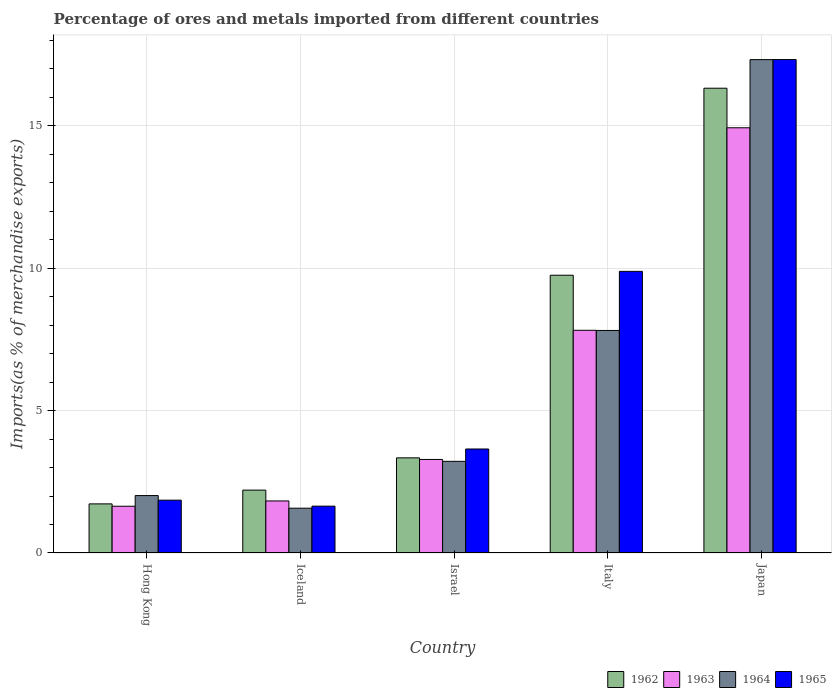How many different coloured bars are there?
Your response must be concise. 4. Are the number of bars per tick equal to the number of legend labels?
Offer a very short reply. Yes. How many bars are there on the 3rd tick from the left?
Your answer should be very brief. 4. How many bars are there on the 1st tick from the right?
Offer a very short reply. 4. What is the percentage of imports to different countries in 1964 in Israel?
Your answer should be very brief. 3.22. Across all countries, what is the maximum percentage of imports to different countries in 1962?
Keep it short and to the point. 16.32. Across all countries, what is the minimum percentage of imports to different countries in 1965?
Your response must be concise. 1.64. In which country was the percentage of imports to different countries in 1963 maximum?
Offer a very short reply. Japan. What is the total percentage of imports to different countries in 1965 in the graph?
Provide a succinct answer. 34.36. What is the difference between the percentage of imports to different countries in 1965 in Italy and that in Japan?
Your response must be concise. -7.44. What is the difference between the percentage of imports to different countries in 1962 in Hong Kong and the percentage of imports to different countries in 1964 in Israel?
Provide a short and direct response. -1.49. What is the average percentage of imports to different countries in 1964 per country?
Ensure brevity in your answer.  6.39. What is the difference between the percentage of imports to different countries of/in 1965 and percentage of imports to different countries of/in 1964 in Hong Kong?
Keep it short and to the point. -0.16. In how many countries, is the percentage of imports to different countries in 1963 greater than 5 %?
Your answer should be compact. 2. What is the ratio of the percentage of imports to different countries in 1964 in Israel to that in Italy?
Your answer should be compact. 0.41. Is the difference between the percentage of imports to different countries in 1965 in Israel and Italy greater than the difference between the percentage of imports to different countries in 1964 in Israel and Italy?
Keep it short and to the point. No. What is the difference between the highest and the second highest percentage of imports to different countries in 1963?
Offer a terse response. -11.64. What is the difference between the highest and the lowest percentage of imports to different countries in 1964?
Keep it short and to the point. 15.75. What does the 2nd bar from the left in Iceland represents?
Ensure brevity in your answer.  1963. How many bars are there?
Ensure brevity in your answer.  20. Are all the bars in the graph horizontal?
Make the answer very short. No. How many countries are there in the graph?
Keep it short and to the point. 5. What is the difference between two consecutive major ticks on the Y-axis?
Your answer should be compact. 5. Are the values on the major ticks of Y-axis written in scientific E-notation?
Provide a succinct answer. No. Does the graph contain any zero values?
Your answer should be very brief. No. Where does the legend appear in the graph?
Make the answer very short. Bottom right. How are the legend labels stacked?
Keep it short and to the point. Horizontal. What is the title of the graph?
Offer a terse response. Percentage of ores and metals imported from different countries. Does "1965" appear as one of the legend labels in the graph?
Your response must be concise. Yes. What is the label or title of the X-axis?
Offer a very short reply. Country. What is the label or title of the Y-axis?
Your answer should be very brief. Imports(as % of merchandise exports). What is the Imports(as % of merchandise exports) of 1962 in Hong Kong?
Your response must be concise. 1.72. What is the Imports(as % of merchandise exports) of 1963 in Hong Kong?
Make the answer very short. 1.64. What is the Imports(as % of merchandise exports) in 1964 in Hong Kong?
Your answer should be very brief. 2.02. What is the Imports(as % of merchandise exports) of 1965 in Hong Kong?
Your answer should be compact. 1.85. What is the Imports(as % of merchandise exports) of 1962 in Iceland?
Give a very brief answer. 2.21. What is the Imports(as % of merchandise exports) in 1963 in Iceland?
Ensure brevity in your answer.  1.83. What is the Imports(as % of merchandise exports) of 1964 in Iceland?
Provide a succinct answer. 1.57. What is the Imports(as % of merchandise exports) in 1965 in Iceland?
Offer a very short reply. 1.64. What is the Imports(as % of merchandise exports) in 1962 in Israel?
Make the answer very short. 3.34. What is the Imports(as % of merchandise exports) of 1963 in Israel?
Offer a very short reply. 3.28. What is the Imports(as % of merchandise exports) of 1964 in Israel?
Your answer should be compact. 3.22. What is the Imports(as % of merchandise exports) of 1965 in Israel?
Offer a very short reply. 3.65. What is the Imports(as % of merchandise exports) in 1962 in Italy?
Offer a very short reply. 9.75. What is the Imports(as % of merchandise exports) of 1963 in Italy?
Offer a very short reply. 7.82. What is the Imports(as % of merchandise exports) in 1964 in Italy?
Your answer should be compact. 7.81. What is the Imports(as % of merchandise exports) of 1965 in Italy?
Ensure brevity in your answer.  9.89. What is the Imports(as % of merchandise exports) of 1962 in Japan?
Your response must be concise. 16.32. What is the Imports(as % of merchandise exports) in 1963 in Japan?
Provide a succinct answer. 14.93. What is the Imports(as % of merchandise exports) of 1964 in Japan?
Offer a very short reply. 17.32. What is the Imports(as % of merchandise exports) in 1965 in Japan?
Offer a terse response. 17.32. Across all countries, what is the maximum Imports(as % of merchandise exports) in 1962?
Your answer should be very brief. 16.32. Across all countries, what is the maximum Imports(as % of merchandise exports) in 1963?
Give a very brief answer. 14.93. Across all countries, what is the maximum Imports(as % of merchandise exports) in 1964?
Give a very brief answer. 17.32. Across all countries, what is the maximum Imports(as % of merchandise exports) of 1965?
Make the answer very short. 17.32. Across all countries, what is the minimum Imports(as % of merchandise exports) in 1962?
Provide a short and direct response. 1.72. Across all countries, what is the minimum Imports(as % of merchandise exports) in 1963?
Keep it short and to the point. 1.64. Across all countries, what is the minimum Imports(as % of merchandise exports) in 1964?
Your answer should be compact. 1.57. Across all countries, what is the minimum Imports(as % of merchandise exports) in 1965?
Provide a succinct answer. 1.64. What is the total Imports(as % of merchandise exports) in 1962 in the graph?
Offer a terse response. 33.34. What is the total Imports(as % of merchandise exports) in 1963 in the graph?
Your answer should be compact. 29.5. What is the total Imports(as % of merchandise exports) in 1964 in the graph?
Ensure brevity in your answer.  31.94. What is the total Imports(as % of merchandise exports) of 1965 in the graph?
Keep it short and to the point. 34.36. What is the difference between the Imports(as % of merchandise exports) of 1962 in Hong Kong and that in Iceland?
Offer a terse response. -0.48. What is the difference between the Imports(as % of merchandise exports) of 1963 in Hong Kong and that in Iceland?
Your answer should be very brief. -0.19. What is the difference between the Imports(as % of merchandise exports) of 1964 in Hong Kong and that in Iceland?
Provide a succinct answer. 0.44. What is the difference between the Imports(as % of merchandise exports) in 1965 in Hong Kong and that in Iceland?
Ensure brevity in your answer.  0.21. What is the difference between the Imports(as % of merchandise exports) in 1962 in Hong Kong and that in Israel?
Provide a short and direct response. -1.62. What is the difference between the Imports(as % of merchandise exports) of 1963 in Hong Kong and that in Israel?
Offer a very short reply. -1.64. What is the difference between the Imports(as % of merchandise exports) in 1964 in Hong Kong and that in Israel?
Your answer should be very brief. -1.2. What is the difference between the Imports(as % of merchandise exports) in 1965 in Hong Kong and that in Israel?
Your answer should be compact. -1.8. What is the difference between the Imports(as % of merchandise exports) of 1962 in Hong Kong and that in Italy?
Make the answer very short. -8.03. What is the difference between the Imports(as % of merchandise exports) of 1963 in Hong Kong and that in Italy?
Your answer should be very brief. -6.18. What is the difference between the Imports(as % of merchandise exports) of 1964 in Hong Kong and that in Italy?
Offer a terse response. -5.8. What is the difference between the Imports(as % of merchandise exports) in 1965 in Hong Kong and that in Italy?
Your response must be concise. -8.03. What is the difference between the Imports(as % of merchandise exports) in 1962 in Hong Kong and that in Japan?
Offer a terse response. -14.59. What is the difference between the Imports(as % of merchandise exports) in 1963 in Hong Kong and that in Japan?
Offer a terse response. -13.29. What is the difference between the Imports(as % of merchandise exports) of 1964 in Hong Kong and that in Japan?
Provide a succinct answer. -15.3. What is the difference between the Imports(as % of merchandise exports) in 1965 in Hong Kong and that in Japan?
Your answer should be compact. -15.47. What is the difference between the Imports(as % of merchandise exports) in 1962 in Iceland and that in Israel?
Your answer should be compact. -1.13. What is the difference between the Imports(as % of merchandise exports) of 1963 in Iceland and that in Israel?
Your response must be concise. -1.46. What is the difference between the Imports(as % of merchandise exports) in 1964 in Iceland and that in Israel?
Ensure brevity in your answer.  -1.65. What is the difference between the Imports(as % of merchandise exports) of 1965 in Iceland and that in Israel?
Give a very brief answer. -2.01. What is the difference between the Imports(as % of merchandise exports) of 1962 in Iceland and that in Italy?
Offer a very short reply. -7.54. What is the difference between the Imports(as % of merchandise exports) in 1963 in Iceland and that in Italy?
Offer a terse response. -5.99. What is the difference between the Imports(as % of merchandise exports) in 1964 in Iceland and that in Italy?
Give a very brief answer. -6.24. What is the difference between the Imports(as % of merchandise exports) in 1965 in Iceland and that in Italy?
Keep it short and to the point. -8.24. What is the difference between the Imports(as % of merchandise exports) of 1962 in Iceland and that in Japan?
Make the answer very short. -14.11. What is the difference between the Imports(as % of merchandise exports) in 1963 in Iceland and that in Japan?
Your answer should be very brief. -13.1. What is the difference between the Imports(as % of merchandise exports) of 1964 in Iceland and that in Japan?
Ensure brevity in your answer.  -15.75. What is the difference between the Imports(as % of merchandise exports) in 1965 in Iceland and that in Japan?
Your response must be concise. -15.68. What is the difference between the Imports(as % of merchandise exports) of 1962 in Israel and that in Italy?
Your response must be concise. -6.41. What is the difference between the Imports(as % of merchandise exports) in 1963 in Israel and that in Italy?
Your response must be concise. -4.53. What is the difference between the Imports(as % of merchandise exports) of 1964 in Israel and that in Italy?
Offer a very short reply. -4.59. What is the difference between the Imports(as % of merchandise exports) of 1965 in Israel and that in Italy?
Make the answer very short. -6.24. What is the difference between the Imports(as % of merchandise exports) in 1962 in Israel and that in Japan?
Provide a short and direct response. -12.98. What is the difference between the Imports(as % of merchandise exports) in 1963 in Israel and that in Japan?
Provide a succinct answer. -11.64. What is the difference between the Imports(as % of merchandise exports) of 1964 in Israel and that in Japan?
Provide a short and direct response. -14.1. What is the difference between the Imports(as % of merchandise exports) of 1965 in Israel and that in Japan?
Offer a very short reply. -13.67. What is the difference between the Imports(as % of merchandise exports) in 1962 in Italy and that in Japan?
Provide a succinct answer. -6.57. What is the difference between the Imports(as % of merchandise exports) of 1963 in Italy and that in Japan?
Provide a succinct answer. -7.11. What is the difference between the Imports(as % of merchandise exports) in 1964 in Italy and that in Japan?
Your response must be concise. -9.51. What is the difference between the Imports(as % of merchandise exports) in 1965 in Italy and that in Japan?
Give a very brief answer. -7.44. What is the difference between the Imports(as % of merchandise exports) in 1962 in Hong Kong and the Imports(as % of merchandise exports) in 1963 in Iceland?
Make the answer very short. -0.1. What is the difference between the Imports(as % of merchandise exports) of 1962 in Hong Kong and the Imports(as % of merchandise exports) of 1964 in Iceland?
Offer a very short reply. 0.15. What is the difference between the Imports(as % of merchandise exports) in 1962 in Hong Kong and the Imports(as % of merchandise exports) in 1965 in Iceland?
Your answer should be compact. 0.08. What is the difference between the Imports(as % of merchandise exports) of 1963 in Hong Kong and the Imports(as % of merchandise exports) of 1964 in Iceland?
Ensure brevity in your answer.  0.07. What is the difference between the Imports(as % of merchandise exports) of 1963 in Hong Kong and the Imports(as % of merchandise exports) of 1965 in Iceland?
Make the answer very short. -0. What is the difference between the Imports(as % of merchandise exports) in 1964 in Hong Kong and the Imports(as % of merchandise exports) in 1965 in Iceland?
Provide a short and direct response. 0.37. What is the difference between the Imports(as % of merchandise exports) in 1962 in Hong Kong and the Imports(as % of merchandise exports) in 1963 in Israel?
Offer a terse response. -1.56. What is the difference between the Imports(as % of merchandise exports) of 1962 in Hong Kong and the Imports(as % of merchandise exports) of 1964 in Israel?
Ensure brevity in your answer.  -1.49. What is the difference between the Imports(as % of merchandise exports) in 1962 in Hong Kong and the Imports(as % of merchandise exports) in 1965 in Israel?
Your response must be concise. -1.93. What is the difference between the Imports(as % of merchandise exports) in 1963 in Hong Kong and the Imports(as % of merchandise exports) in 1964 in Israel?
Make the answer very short. -1.58. What is the difference between the Imports(as % of merchandise exports) in 1963 in Hong Kong and the Imports(as % of merchandise exports) in 1965 in Israel?
Keep it short and to the point. -2.01. What is the difference between the Imports(as % of merchandise exports) of 1964 in Hong Kong and the Imports(as % of merchandise exports) of 1965 in Israel?
Your answer should be compact. -1.64. What is the difference between the Imports(as % of merchandise exports) in 1962 in Hong Kong and the Imports(as % of merchandise exports) in 1963 in Italy?
Provide a succinct answer. -6.09. What is the difference between the Imports(as % of merchandise exports) of 1962 in Hong Kong and the Imports(as % of merchandise exports) of 1964 in Italy?
Offer a terse response. -6.09. What is the difference between the Imports(as % of merchandise exports) in 1962 in Hong Kong and the Imports(as % of merchandise exports) in 1965 in Italy?
Your answer should be compact. -8.16. What is the difference between the Imports(as % of merchandise exports) in 1963 in Hong Kong and the Imports(as % of merchandise exports) in 1964 in Italy?
Give a very brief answer. -6.17. What is the difference between the Imports(as % of merchandise exports) of 1963 in Hong Kong and the Imports(as % of merchandise exports) of 1965 in Italy?
Give a very brief answer. -8.25. What is the difference between the Imports(as % of merchandise exports) of 1964 in Hong Kong and the Imports(as % of merchandise exports) of 1965 in Italy?
Provide a succinct answer. -7.87. What is the difference between the Imports(as % of merchandise exports) of 1962 in Hong Kong and the Imports(as % of merchandise exports) of 1963 in Japan?
Keep it short and to the point. -13.2. What is the difference between the Imports(as % of merchandise exports) of 1962 in Hong Kong and the Imports(as % of merchandise exports) of 1964 in Japan?
Provide a succinct answer. -15.6. What is the difference between the Imports(as % of merchandise exports) in 1962 in Hong Kong and the Imports(as % of merchandise exports) in 1965 in Japan?
Provide a succinct answer. -15.6. What is the difference between the Imports(as % of merchandise exports) of 1963 in Hong Kong and the Imports(as % of merchandise exports) of 1964 in Japan?
Give a very brief answer. -15.68. What is the difference between the Imports(as % of merchandise exports) in 1963 in Hong Kong and the Imports(as % of merchandise exports) in 1965 in Japan?
Provide a succinct answer. -15.68. What is the difference between the Imports(as % of merchandise exports) of 1964 in Hong Kong and the Imports(as % of merchandise exports) of 1965 in Japan?
Provide a short and direct response. -15.31. What is the difference between the Imports(as % of merchandise exports) of 1962 in Iceland and the Imports(as % of merchandise exports) of 1963 in Israel?
Ensure brevity in your answer.  -1.08. What is the difference between the Imports(as % of merchandise exports) of 1962 in Iceland and the Imports(as % of merchandise exports) of 1964 in Israel?
Provide a succinct answer. -1.01. What is the difference between the Imports(as % of merchandise exports) in 1962 in Iceland and the Imports(as % of merchandise exports) in 1965 in Israel?
Give a very brief answer. -1.44. What is the difference between the Imports(as % of merchandise exports) in 1963 in Iceland and the Imports(as % of merchandise exports) in 1964 in Israel?
Provide a short and direct response. -1.39. What is the difference between the Imports(as % of merchandise exports) of 1963 in Iceland and the Imports(as % of merchandise exports) of 1965 in Israel?
Make the answer very short. -1.82. What is the difference between the Imports(as % of merchandise exports) of 1964 in Iceland and the Imports(as % of merchandise exports) of 1965 in Israel?
Give a very brief answer. -2.08. What is the difference between the Imports(as % of merchandise exports) in 1962 in Iceland and the Imports(as % of merchandise exports) in 1963 in Italy?
Ensure brevity in your answer.  -5.61. What is the difference between the Imports(as % of merchandise exports) in 1962 in Iceland and the Imports(as % of merchandise exports) in 1964 in Italy?
Provide a short and direct response. -5.61. What is the difference between the Imports(as % of merchandise exports) in 1962 in Iceland and the Imports(as % of merchandise exports) in 1965 in Italy?
Provide a short and direct response. -7.68. What is the difference between the Imports(as % of merchandise exports) in 1963 in Iceland and the Imports(as % of merchandise exports) in 1964 in Italy?
Your answer should be compact. -5.98. What is the difference between the Imports(as % of merchandise exports) of 1963 in Iceland and the Imports(as % of merchandise exports) of 1965 in Italy?
Ensure brevity in your answer.  -8.06. What is the difference between the Imports(as % of merchandise exports) in 1964 in Iceland and the Imports(as % of merchandise exports) in 1965 in Italy?
Make the answer very short. -8.31. What is the difference between the Imports(as % of merchandise exports) of 1962 in Iceland and the Imports(as % of merchandise exports) of 1963 in Japan?
Ensure brevity in your answer.  -12.72. What is the difference between the Imports(as % of merchandise exports) of 1962 in Iceland and the Imports(as % of merchandise exports) of 1964 in Japan?
Ensure brevity in your answer.  -15.11. What is the difference between the Imports(as % of merchandise exports) of 1962 in Iceland and the Imports(as % of merchandise exports) of 1965 in Japan?
Offer a very short reply. -15.12. What is the difference between the Imports(as % of merchandise exports) in 1963 in Iceland and the Imports(as % of merchandise exports) in 1964 in Japan?
Ensure brevity in your answer.  -15.49. What is the difference between the Imports(as % of merchandise exports) in 1963 in Iceland and the Imports(as % of merchandise exports) in 1965 in Japan?
Offer a very short reply. -15.5. What is the difference between the Imports(as % of merchandise exports) of 1964 in Iceland and the Imports(as % of merchandise exports) of 1965 in Japan?
Provide a succinct answer. -15.75. What is the difference between the Imports(as % of merchandise exports) of 1962 in Israel and the Imports(as % of merchandise exports) of 1963 in Italy?
Provide a succinct answer. -4.48. What is the difference between the Imports(as % of merchandise exports) of 1962 in Israel and the Imports(as % of merchandise exports) of 1964 in Italy?
Keep it short and to the point. -4.47. What is the difference between the Imports(as % of merchandise exports) of 1962 in Israel and the Imports(as % of merchandise exports) of 1965 in Italy?
Your answer should be compact. -6.55. What is the difference between the Imports(as % of merchandise exports) of 1963 in Israel and the Imports(as % of merchandise exports) of 1964 in Italy?
Your response must be concise. -4.53. What is the difference between the Imports(as % of merchandise exports) in 1963 in Israel and the Imports(as % of merchandise exports) in 1965 in Italy?
Your answer should be very brief. -6.6. What is the difference between the Imports(as % of merchandise exports) of 1964 in Israel and the Imports(as % of merchandise exports) of 1965 in Italy?
Make the answer very short. -6.67. What is the difference between the Imports(as % of merchandise exports) in 1962 in Israel and the Imports(as % of merchandise exports) in 1963 in Japan?
Your answer should be very brief. -11.59. What is the difference between the Imports(as % of merchandise exports) of 1962 in Israel and the Imports(as % of merchandise exports) of 1964 in Japan?
Your answer should be compact. -13.98. What is the difference between the Imports(as % of merchandise exports) in 1962 in Israel and the Imports(as % of merchandise exports) in 1965 in Japan?
Provide a short and direct response. -13.98. What is the difference between the Imports(as % of merchandise exports) in 1963 in Israel and the Imports(as % of merchandise exports) in 1964 in Japan?
Your answer should be compact. -14.04. What is the difference between the Imports(as % of merchandise exports) of 1963 in Israel and the Imports(as % of merchandise exports) of 1965 in Japan?
Make the answer very short. -14.04. What is the difference between the Imports(as % of merchandise exports) in 1964 in Israel and the Imports(as % of merchandise exports) in 1965 in Japan?
Provide a succinct answer. -14.11. What is the difference between the Imports(as % of merchandise exports) of 1962 in Italy and the Imports(as % of merchandise exports) of 1963 in Japan?
Offer a very short reply. -5.18. What is the difference between the Imports(as % of merchandise exports) in 1962 in Italy and the Imports(as % of merchandise exports) in 1964 in Japan?
Provide a short and direct response. -7.57. What is the difference between the Imports(as % of merchandise exports) in 1962 in Italy and the Imports(as % of merchandise exports) in 1965 in Japan?
Give a very brief answer. -7.57. What is the difference between the Imports(as % of merchandise exports) in 1963 in Italy and the Imports(as % of merchandise exports) in 1964 in Japan?
Your response must be concise. -9.5. What is the difference between the Imports(as % of merchandise exports) in 1963 in Italy and the Imports(as % of merchandise exports) in 1965 in Japan?
Offer a terse response. -9.51. What is the difference between the Imports(as % of merchandise exports) in 1964 in Italy and the Imports(as % of merchandise exports) in 1965 in Japan?
Make the answer very short. -9.51. What is the average Imports(as % of merchandise exports) in 1962 per country?
Your answer should be very brief. 6.67. What is the average Imports(as % of merchandise exports) of 1963 per country?
Your response must be concise. 5.9. What is the average Imports(as % of merchandise exports) of 1964 per country?
Keep it short and to the point. 6.39. What is the average Imports(as % of merchandise exports) of 1965 per country?
Offer a terse response. 6.87. What is the difference between the Imports(as % of merchandise exports) in 1962 and Imports(as % of merchandise exports) in 1963 in Hong Kong?
Your answer should be compact. 0.08. What is the difference between the Imports(as % of merchandise exports) of 1962 and Imports(as % of merchandise exports) of 1964 in Hong Kong?
Provide a short and direct response. -0.29. What is the difference between the Imports(as % of merchandise exports) of 1962 and Imports(as % of merchandise exports) of 1965 in Hong Kong?
Provide a succinct answer. -0.13. What is the difference between the Imports(as % of merchandise exports) in 1963 and Imports(as % of merchandise exports) in 1964 in Hong Kong?
Your response must be concise. -0.37. What is the difference between the Imports(as % of merchandise exports) of 1963 and Imports(as % of merchandise exports) of 1965 in Hong Kong?
Your response must be concise. -0.21. What is the difference between the Imports(as % of merchandise exports) in 1964 and Imports(as % of merchandise exports) in 1965 in Hong Kong?
Your answer should be very brief. 0.16. What is the difference between the Imports(as % of merchandise exports) of 1962 and Imports(as % of merchandise exports) of 1963 in Iceland?
Provide a succinct answer. 0.38. What is the difference between the Imports(as % of merchandise exports) of 1962 and Imports(as % of merchandise exports) of 1964 in Iceland?
Provide a succinct answer. 0.63. What is the difference between the Imports(as % of merchandise exports) in 1962 and Imports(as % of merchandise exports) in 1965 in Iceland?
Keep it short and to the point. 0.56. What is the difference between the Imports(as % of merchandise exports) of 1963 and Imports(as % of merchandise exports) of 1964 in Iceland?
Make the answer very short. 0.25. What is the difference between the Imports(as % of merchandise exports) of 1963 and Imports(as % of merchandise exports) of 1965 in Iceland?
Offer a terse response. 0.18. What is the difference between the Imports(as % of merchandise exports) in 1964 and Imports(as % of merchandise exports) in 1965 in Iceland?
Your answer should be compact. -0.07. What is the difference between the Imports(as % of merchandise exports) in 1962 and Imports(as % of merchandise exports) in 1963 in Israel?
Provide a succinct answer. 0.06. What is the difference between the Imports(as % of merchandise exports) of 1962 and Imports(as % of merchandise exports) of 1964 in Israel?
Offer a terse response. 0.12. What is the difference between the Imports(as % of merchandise exports) in 1962 and Imports(as % of merchandise exports) in 1965 in Israel?
Offer a very short reply. -0.31. What is the difference between the Imports(as % of merchandise exports) of 1963 and Imports(as % of merchandise exports) of 1964 in Israel?
Provide a succinct answer. 0.07. What is the difference between the Imports(as % of merchandise exports) of 1963 and Imports(as % of merchandise exports) of 1965 in Israel?
Provide a succinct answer. -0.37. What is the difference between the Imports(as % of merchandise exports) in 1964 and Imports(as % of merchandise exports) in 1965 in Israel?
Provide a short and direct response. -0.43. What is the difference between the Imports(as % of merchandise exports) of 1962 and Imports(as % of merchandise exports) of 1963 in Italy?
Give a very brief answer. 1.93. What is the difference between the Imports(as % of merchandise exports) in 1962 and Imports(as % of merchandise exports) in 1964 in Italy?
Provide a succinct answer. 1.94. What is the difference between the Imports(as % of merchandise exports) in 1962 and Imports(as % of merchandise exports) in 1965 in Italy?
Ensure brevity in your answer.  -0.14. What is the difference between the Imports(as % of merchandise exports) of 1963 and Imports(as % of merchandise exports) of 1964 in Italy?
Your answer should be compact. 0.01. What is the difference between the Imports(as % of merchandise exports) of 1963 and Imports(as % of merchandise exports) of 1965 in Italy?
Make the answer very short. -2.07. What is the difference between the Imports(as % of merchandise exports) of 1964 and Imports(as % of merchandise exports) of 1965 in Italy?
Your answer should be very brief. -2.08. What is the difference between the Imports(as % of merchandise exports) of 1962 and Imports(as % of merchandise exports) of 1963 in Japan?
Ensure brevity in your answer.  1.39. What is the difference between the Imports(as % of merchandise exports) in 1962 and Imports(as % of merchandise exports) in 1964 in Japan?
Provide a succinct answer. -1. What is the difference between the Imports(as % of merchandise exports) in 1962 and Imports(as % of merchandise exports) in 1965 in Japan?
Ensure brevity in your answer.  -1.01. What is the difference between the Imports(as % of merchandise exports) of 1963 and Imports(as % of merchandise exports) of 1964 in Japan?
Provide a short and direct response. -2.39. What is the difference between the Imports(as % of merchandise exports) of 1963 and Imports(as % of merchandise exports) of 1965 in Japan?
Offer a terse response. -2.4. What is the difference between the Imports(as % of merchandise exports) in 1964 and Imports(as % of merchandise exports) in 1965 in Japan?
Your answer should be very brief. -0. What is the ratio of the Imports(as % of merchandise exports) in 1962 in Hong Kong to that in Iceland?
Your answer should be compact. 0.78. What is the ratio of the Imports(as % of merchandise exports) in 1963 in Hong Kong to that in Iceland?
Offer a terse response. 0.9. What is the ratio of the Imports(as % of merchandise exports) in 1964 in Hong Kong to that in Iceland?
Offer a very short reply. 1.28. What is the ratio of the Imports(as % of merchandise exports) of 1965 in Hong Kong to that in Iceland?
Your answer should be very brief. 1.13. What is the ratio of the Imports(as % of merchandise exports) in 1962 in Hong Kong to that in Israel?
Keep it short and to the point. 0.52. What is the ratio of the Imports(as % of merchandise exports) of 1963 in Hong Kong to that in Israel?
Your answer should be very brief. 0.5. What is the ratio of the Imports(as % of merchandise exports) in 1964 in Hong Kong to that in Israel?
Keep it short and to the point. 0.63. What is the ratio of the Imports(as % of merchandise exports) in 1965 in Hong Kong to that in Israel?
Provide a succinct answer. 0.51. What is the ratio of the Imports(as % of merchandise exports) in 1962 in Hong Kong to that in Italy?
Your response must be concise. 0.18. What is the ratio of the Imports(as % of merchandise exports) in 1963 in Hong Kong to that in Italy?
Make the answer very short. 0.21. What is the ratio of the Imports(as % of merchandise exports) in 1964 in Hong Kong to that in Italy?
Provide a short and direct response. 0.26. What is the ratio of the Imports(as % of merchandise exports) of 1965 in Hong Kong to that in Italy?
Make the answer very short. 0.19. What is the ratio of the Imports(as % of merchandise exports) in 1962 in Hong Kong to that in Japan?
Make the answer very short. 0.11. What is the ratio of the Imports(as % of merchandise exports) of 1963 in Hong Kong to that in Japan?
Offer a terse response. 0.11. What is the ratio of the Imports(as % of merchandise exports) in 1964 in Hong Kong to that in Japan?
Provide a short and direct response. 0.12. What is the ratio of the Imports(as % of merchandise exports) of 1965 in Hong Kong to that in Japan?
Your answer should be compact. 0.11. What is the ratio of the Imports(as % of merchandise exports) in 1962 in Iceland to that in Israel?
Provide a short and direct response. 0.66. What is the ratio of the Imports(as % of merchandise exports) of 1963 in Iceland to that in Israel?
Make the answer very short. 0.56. What is the ratio of the Imports(as % of merchandise exports) in 1964 in Iceland to that in Israel?
Provide a short and direct response. 0.49. What is the ratio of the Imports(as % of merchandise exports) in 1965 in Iceland to that in Israel?
Ensure brevity in your answer.  0.45. What is the ratio of the Imports(as % of merchandise exports) in 1962 in Iceland to that in Italy?
Make the answer very short. 0.23. What is the ratio of the Imports(as % of merchandise exports) in 1963 in Iceland to that in Italy?
Offer a very short reply. 0.23. What is the ratio of the Imports(as % of merchandise exports) in 1964 in Iceland to that in Italy?
Your answer should be compact. 0.2. What is the ratio of the Imports(as % of merchandise exports) of 1965 in Iceland to that in Italy?
Keep it short and to the point. 0.17. What is the ratio of the Imports(as % of merchandise exports) in 1962 in Iceland to that in Japan?
Make the answer very short. 0.14. What is the ratio of the Imports(as % of merchandise exports) of 1963 in Iceland to that in Japan?
Your answer should be compact. 0.12. What is the ratio of the Imports(as % of merchandise exports) of 1964 in Iceland to that in Japan?
Keep it short and to the point. 0.09. What is the ratio of the Imports(as % of merchandise exports) of 1965 in Iceland to that in Japan?
Make the answer very short. 0.09. What is the ratio of the Imports(as % of merchandise exports) in 1962 in Israel to that in Italy?
Your answer should be compact. 0.34. What is the ratio of the Imports(as % of merchandise exports) of 1963 in Israel to that in Italy?
Make the answer very short. 0.42. What is the ratio of the Imports(as % of merchandise exports) of 1964 in Israel to that in Italy?
Offer a terse response. 0.41. What is the ratio of the Imports(as % of merchandise exports) of 1965 in Israel to that in Italy?
Offer a terse response. 0.37. What is the ratio of the Imports(as % of merchandise exports) in 1962 in Israel to that in Japan?
Your response must be concise. 0.2. What is the ratio of the Imports(as % of merchandise exports) of 1963 in Israel to that in Japan?
Provide a short and direct response. 0.22. What is the ratio of the Imports(as % of merchandise exports) of 1964 in Israel to that in Japan?
Your answer should be compact. 0.19. What is the ratio of the Imports(as % of merchandise exports) in 1965 in Israel to that in Japan?
Offer a very short reply. 0.21. What is the ratio of the Imports(as % of merchandise exports) of 1962 in Italy to that in Japan?
Give a very brief answer. 0.6. What is the ratio of the Imports(as % of merchandise exports) of 1963 in Italy to that in Japan?
Offer a terse response. 0.52. What is the ratio of the Imports(as % of merchandise exports) of 1964 in Italy to that in Japan?
Make the answer very short. 0.45. What is the ratio of the Imports(as % of merchandise exports) of 1965 in Italy to that in Japan?
Keep it short and to the point. 0.57. What is the difference between the highest and the second highest Imports(as % of merchandise exports) in 1962?
Offer a very short reply. 6.57. What is the difference between the highest and the second highest Imports(as % of merchandise exports) in 1963?
Give a very brief answer. 7.11. What is the difference between the highest and the second highest Imports(as % of merchandise exports) of 1964?
Provide a short and direct response. 9.51. What is the difference between the highest and the second highest Imports(as % of merchandise exports) in 1965?
Your answer should be compact. 7.44. What is the difference between the highest and the lowest Imports(as % of merchandise exports) in 1962?
Make the answer very short. 14.59. What is the difference between the highest and the lowest Imports(as % of merchandise exports) in 1963?
Ensure brevity in your answer.  13.29. What is the difference between the highest and the lowest Imports(as % of merchandise exports) in 1964?
Keep it short and to the point. 15.75. What is the difference between the highest and the lowest Imports(as % of merchandise exports) in 1965?
Offer a terse response. 15.68. 